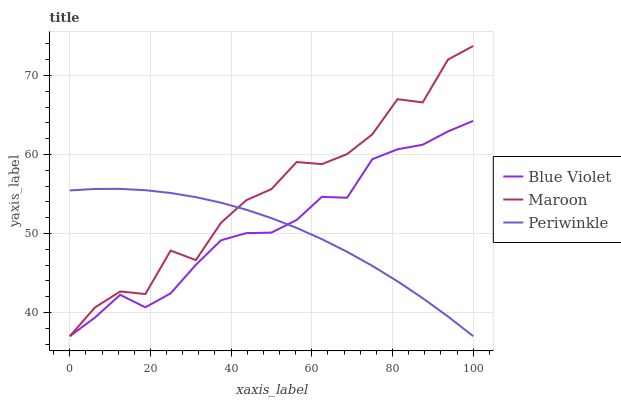Does Blue Violet have the minimum area under the curve?
Answer yes or no. No. Does Blue Violet have the maximum area under the curve?
Answer yes or no. No. Is Blue Violet the smoothest?
Answer yes or no. No. Is Blue Violet the roughest?
Answer yes or no. No. Does Blue Violet have the highest value?
Answer yes or no. No. 